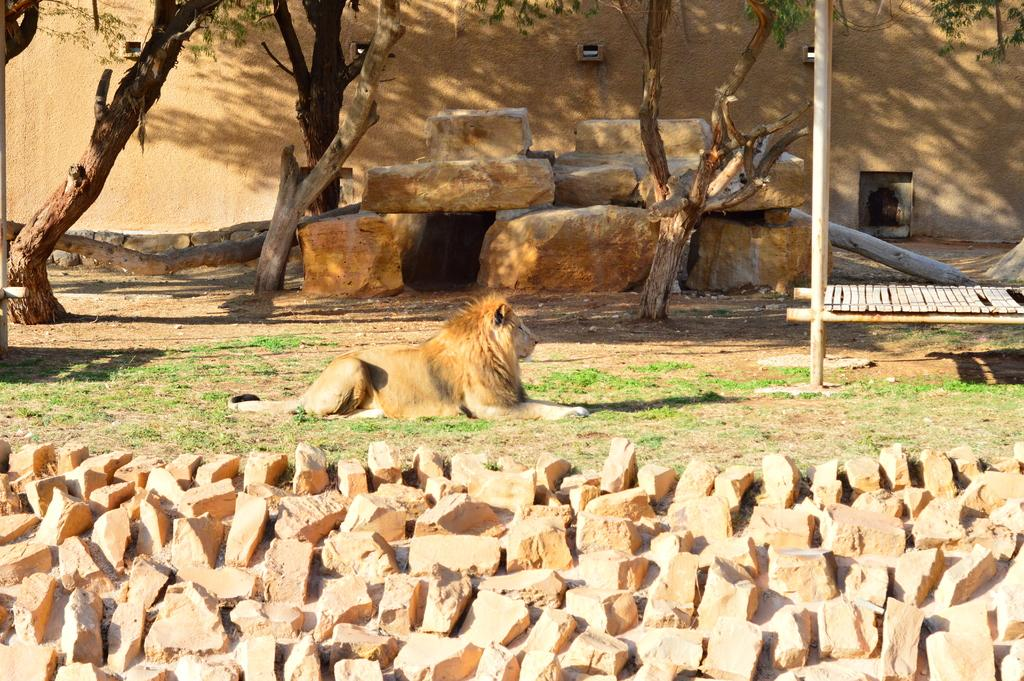What is at the bottom of the image? There are stones at the bottom of the image. What animal is sitting on the floor in the middle of the image? A lion is sitting on the floor in the middle of the image. What type of vegetation can be seen in the image? There are trees in the image. What structure is visible at the back side of the image? There is a wall visible at the back side of the image. What type of kitten can be seen playing with the lion in the image? There is no kitten present in the image, and the lion is sitting alone on the floor. What type of flesh can be seen on the lion in the image? The image does not show any flesh, only the lion's fur and the stones at the bottom. 